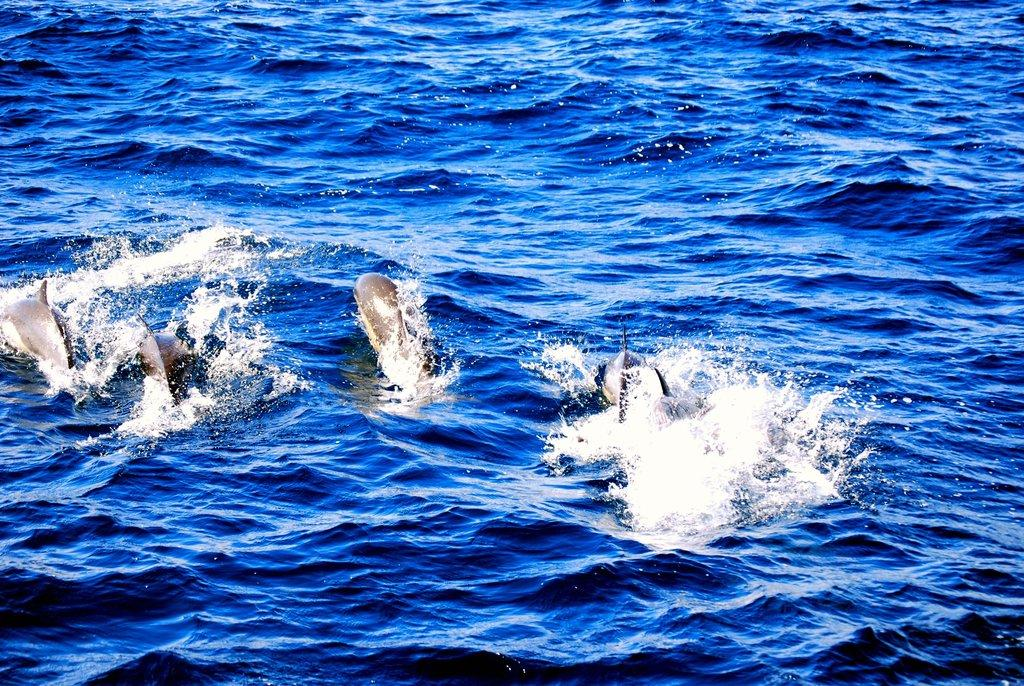Where was the picture taken? The picture was clicked outside the city. What can be seen in the image besides the location? There is a water body in the image. What type of creatures can be seen in the water body? Sea animals are present in the water body. What is the condition of the water body in the image? Ripples are visible in the water body. Can you see a crown on the head of any sea animal in the image? There is no crown visible on any sea animal in the image. Is there a bridge crossing the water body in the image? There is no bridge present in the image; it only features a water body with sea animals and ripples. 